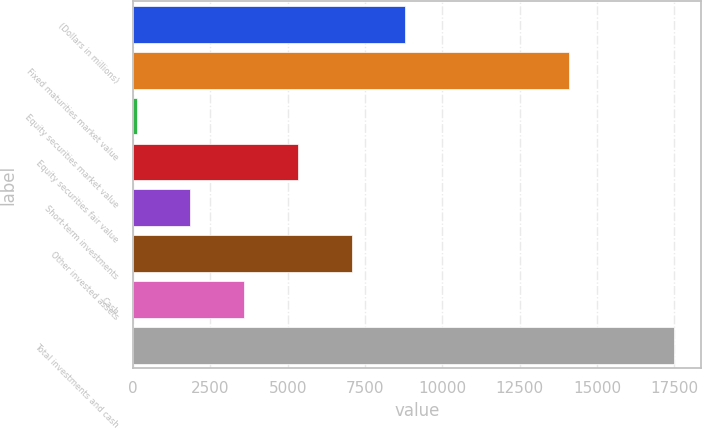Convert chart to OTSL. <chart><loc_0><loc_0><loc_500><loc_500><bar_chart><fcel>(Dollars in millions)<fcel>Fixed maturities market value<fcel>Equity securities market value<fcel>Equity securities fair value<fcel>Short-term investments<fcel>Other invested assets<fcel>Cash<fcel>Total investments and cash<nl><fcel>8801.1<fcel>14107.4<fcel>119.1<fcel>5328.3<fcel>1855.5<fcel>7064.7<fcel>3591.9<fcel>17483.1<nl></chart> 